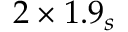Convert formula to latex. <formula><loc_0><loc_0><loc_500><loc_500>2 \times 1 . 9 _ { s }</formula> 